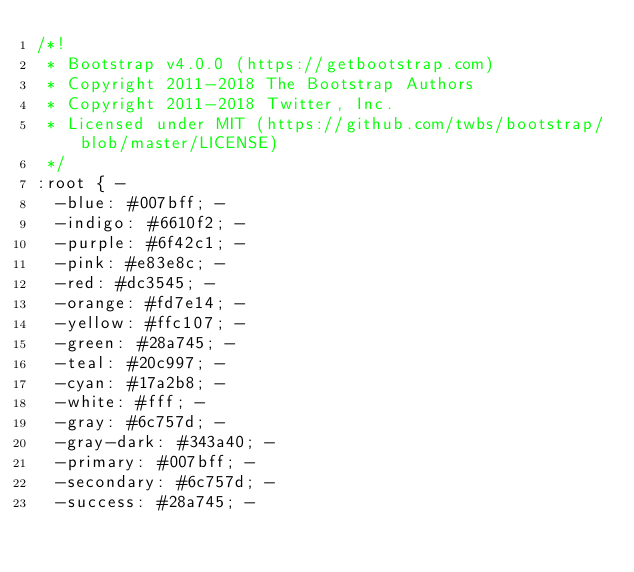Convert code to text. <code><loc_0><loc_0><loc_500><loc_500><_CSS_>/*!
 * Bootstrap v4.0.0 (https://getbootstrap.com)
 * Copyright 2011-2018 The Bootstrap Authors
 * Copyright 2011-2018 Twitter, Inc.
 * Licensed under MIT (https://github.com/twbs/bootstrap/blob/master/LICENSE)
 */
:root { -
	-blue: #007bff; -
	-indigo: #6610f2; -
	-purple: #6f42c1; -
	-pink: #e83e8c; -
	-red: #dc3545; -
	-orange: #fd7e14; -
	-yellow: #ffc107; -
	-green: #28a745; -
	-teal: #20c997; -
	-cyan: #17a2b8; -
	-white: #fff; -
	-gray: #6c757d; -
	-gray-dark: #343a40; -
	-primary: #007bff; -
	-secondary: #6c757d; -
	-success: #28a745; -</code> 